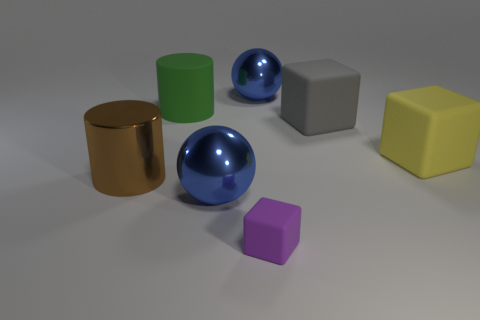Subtract all small purple blocks. How many blocks are left? 2 Subtract all yellow blocks. How many blocks are left? 2 Subtract 0 red balls. How many objects are left? 7 Subtract all cubes. How many objects are left? 4 Subtract 1 blocks. How many blocks are left? 2 Subtract all blue cylinders. Subtract all yellow blocks. How many cylinders are left? 2 Subtract all purple balls. How many gray cubes are left? 1 Subtract all brown cylinders. Subtract all big blue balls. How many objects are left? 4 Add 5 gray blocks. How many gray blocks are left? 6 Add 6 large yellow metal things. How many large yellow metal things exist? 6 